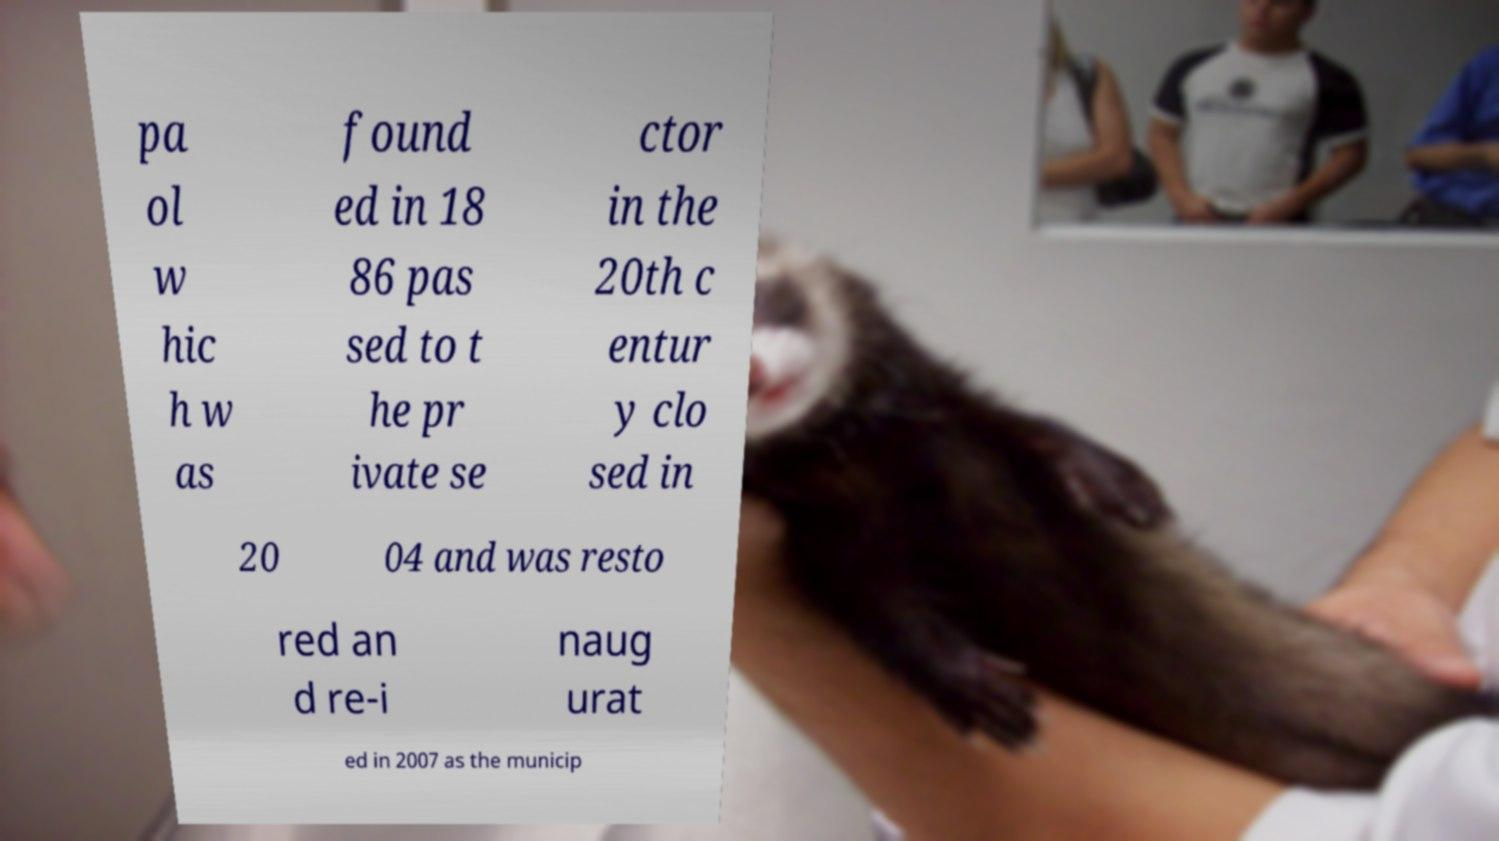What messages or text are displayed in this image? I need them in a readable, typed format. pa ol w hic h w as found ed in 18 86 pas sed to t he pr ivate se ctor in the 20th c entur y clo sed in 20 04 and was resto red an d re-i naug urat ed in 2007 as the municip 